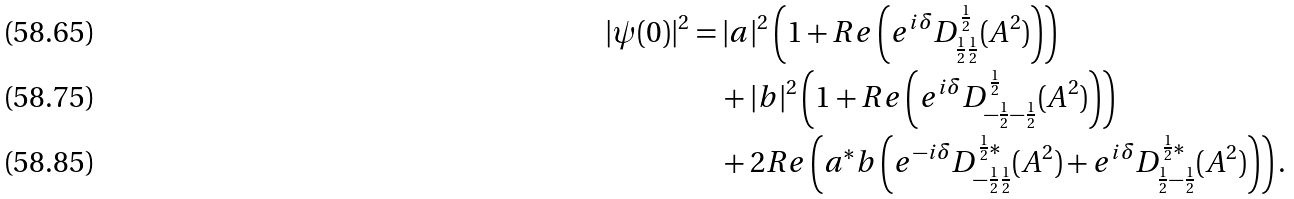<formula> <loc_0><loc_0><loc_500><loc_500>| \psi ( 0 ) | ^ { 2 } & = | a | ^ { 2 } \left ( 1 + R e \left ( e ^ { i \delta } D _ { \frac { 1 } { 2 } \frac { 1 } { 2 } } ^ { \frac { 1 } { 2 } } ( A ^ { 2 } ) \right ) \right ) \\ & \quad + | b | ^ { 2 } \left ( 1 + R e \left ( e ^ { i \delta } D _ { - \frac { 1 } { 2 } - \frac { 1 } { 2 } } ^ { \frac { 1 } { 2 } } ( A ^ { 2 } ) \right ) \right ) \\ & \quad + 2 R e \left ( a ^ { * } b \left ( e ^ { - i \delta } D _ { - \frac { 1 } { 2 } \frac { 1 } { 2 } } ^ { \frac { 1 } { 2 } * } ( A ^ { 2 } ) + e ^ { i \delta } D _ { \frac { 1 } { 2 } - \frac { 1 } { 2 } } ^ { \frac { 1 } { 2 } * } ( A ^ { 2 } ) \right ) \right ) .</formula> 